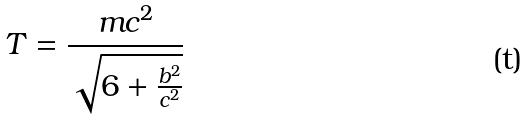Convert formula to latex. <formula><loc_0><loc_0><loc_500><loc_500>T = \frac { m c ^ { 2 } } { \sqrt { 6 + \frac { b ^ { 2 } } { c ^ { 2 } } } }</formula> 